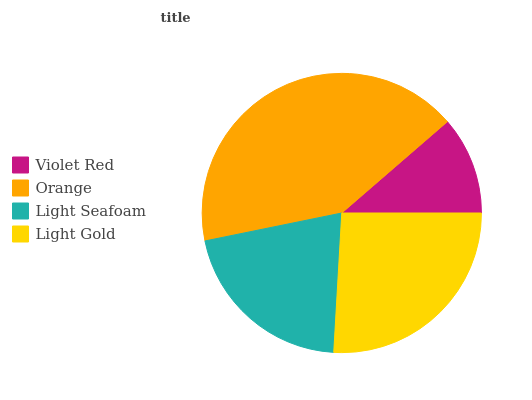Is Violet Red the minimum?
Answer yes or no. Yes. Is Orange the maximum?
Answer yes or no. Yes. Is Light Seafoam the minimum?
Answer yes or no. No. Is Light Seafoam the maximum?
Answer yes or no. No. Is Orange greater than Light Seafoam?
Answer yes or no. Yes. Is Light Seafoam less than Orange?
Answer yes or no. Yes. Is Light Seafoam greater than Orange?
Answer yes or no. No. Is Orange less than Light Seafoam?
Answer yes or no. No. Is Light Gold the high median?
Answer yes or no. Yes. Is Light Seafoam the low median?
Answer yes or no. Yes. Is Light Seafoam the high median?
Answer yes or no. No. Is Orange the low median?
Answer yes or no. No. 